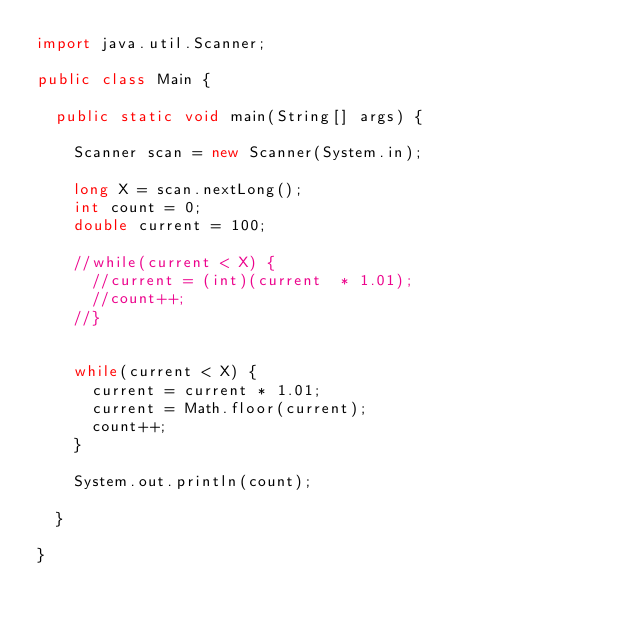Convert code to text. <code><loc_0><loc_0><loc_500><loc_500><_Java_>import java.util.Scanner;

public class Main {

	public static void main(String[] args) {

		Scanner scan = new Scanner(System.in);

		long X = scan.nextLong();
		int count = 0;
		double current = 100;

		//while(current < X) {
			//current = (int)(current  * 1.01);
			//count++;
		//}


		while(current < X) {
			current = current * 1.01;
			current = Math.floor(current);
			count++;
		}

		System.out.println(count);

	}

}</code> 